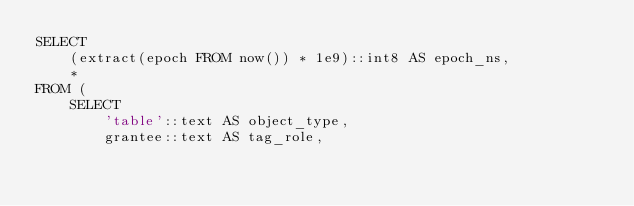<code> <loc_0><loc_0><loc_500><loc_500><_SQL_>SELECT
    (extract(epoch FROM now()) * 1e9)::int8 AS epoch_ns,
    *
FROM (
    SELECT
        'table'::text AS object_type,
        grantee::text AS tag_role,</code> 